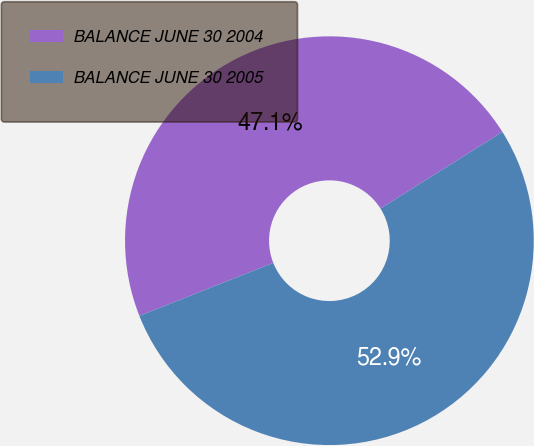Convert chart to OTSL. <chart><loc_0><loc_0><loc_500><loc_500><pie_chart><fcel>BALANCE JUNE 30 2004<fcel>BALANCE JUNE 30 2005<nl><fcel>47.06%<fcel>52.94%<nl></chart> 